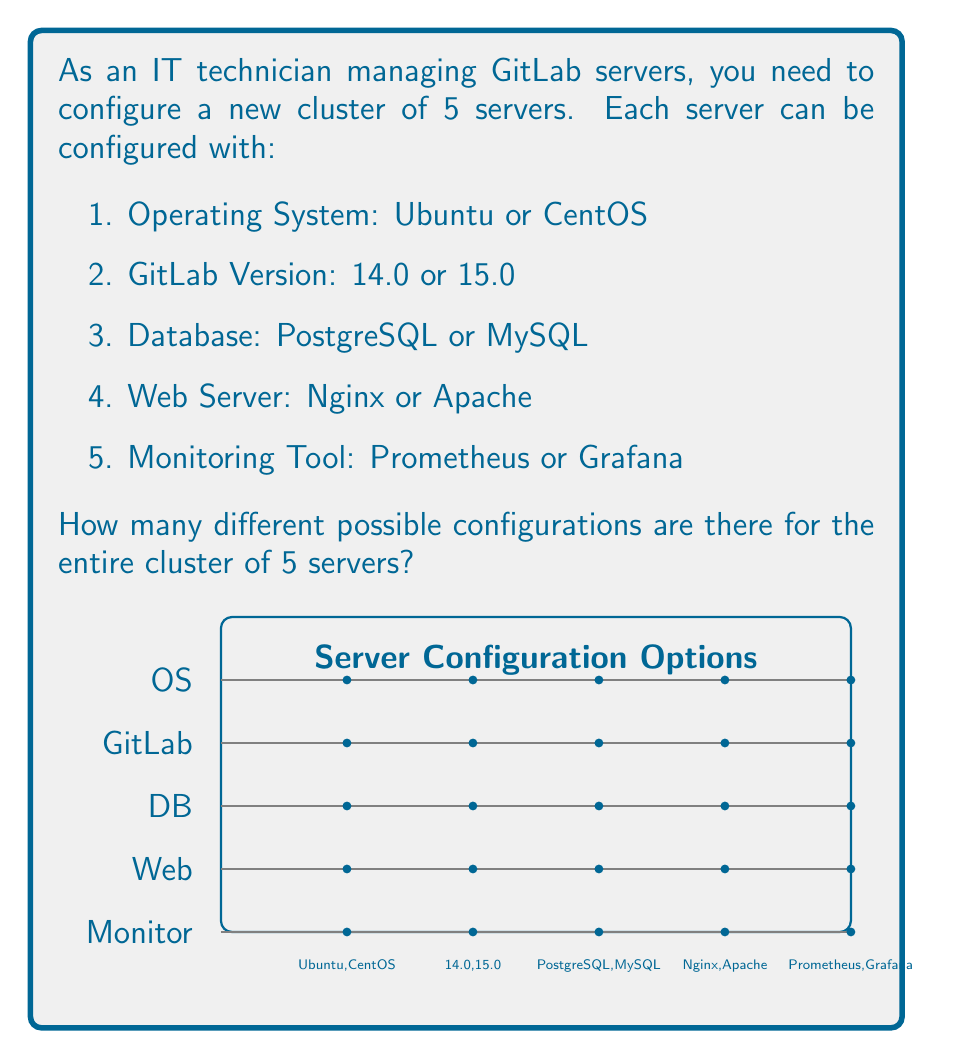Solve this math problem. Let's approach this step-by-step:

1) First, we need to calculate how many possible configurations there are for a single server:

   - Operating System: 2 choices
   - GitLab Version: 2 choices
   - Database: 2 choices
   - Web Server: 2 choices
   - Monitoring Tool: 2 choices

2) For each server, we apply the multiplication principle. The total number of configurations for one server is:

   $$ 2 \times 2 \times 2 \times 2 \times 2 = 2^5 = 32 $$

3) Now, we have 5 servers in the cluster, and each server can be configured independently. This means we're dealing with a combination with repetition allowed.

4) In combinatorics, when we have n independent events, each with m possible outcomes, the total number of possible combinations is $m^n$.

5) In this case:
   - n = 5 (number of servers)
   - m = 32 (number of possible configurations for each server)

6) Therefore, the total number of possible configurations for the cluster is:

   $$ 32^5 = (2^5)^5 = 2^{25} = 33,554,432 $$

Thus, there are 33,554,432 different possible configurations for the entire cluster of 5 servers.
Answer: $2^{25} = 33,554,432$ 